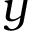Convert formula to latex. <formula><loc_0><loc_0><loc_500><loc_500>y</formula> 